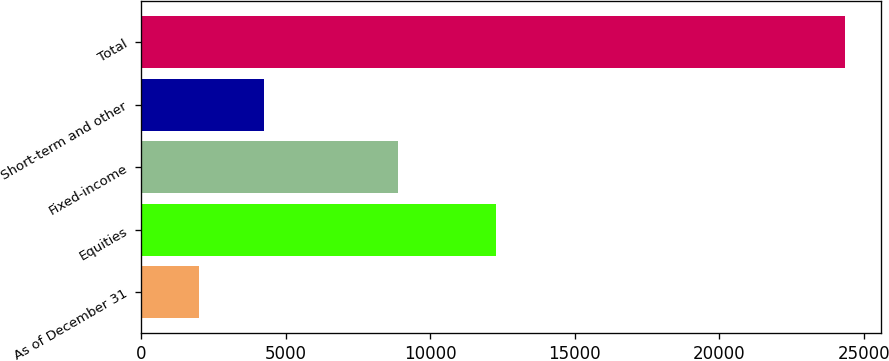<chart> <loc_0><loc_0><loc_500><loc_500><bar_chart><fcel>As of December 31<fcel>Equities<fcel>Fixed-income<fcel>Short-term and other<fcel>Total<nl><fcel>2012<fcel>12276<fcel>8885<fcel>4247.9<fcel>24371<nl></chart> 